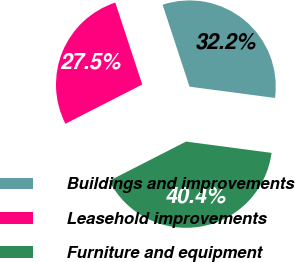Convert chart to OTSL. <chart><loc_0><loc_0><loc_500><loc_500><pie_chart><fcel>Buildings and improvements<fcel>Leasehold improvements<fcel>Furniture and equipment<nl><fcel>32.15%<fcel>27.46%<fcel>40.39%<nl></chart> 